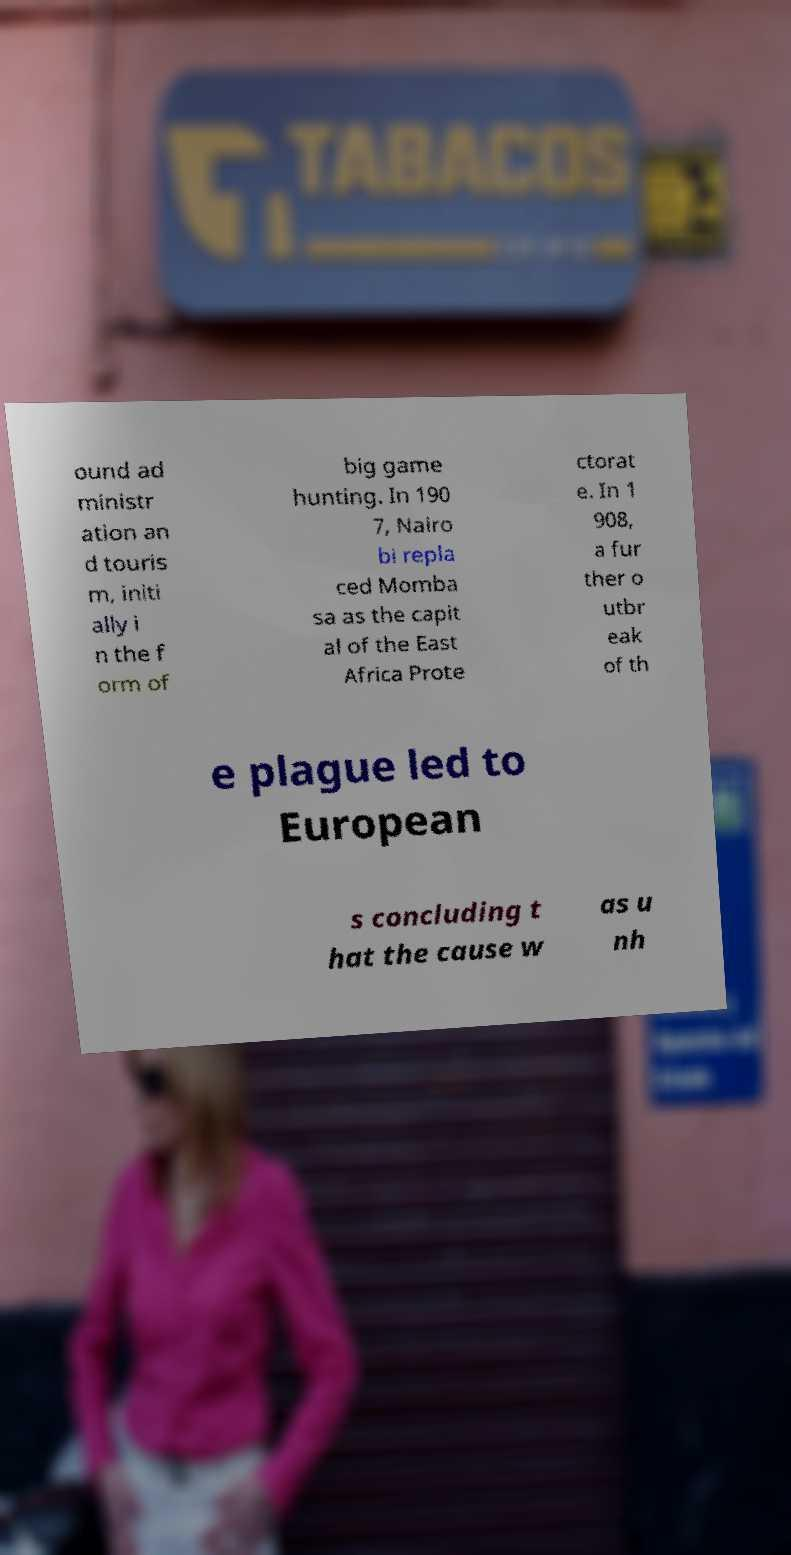Please identify and transcribe the text found in this image. ound ad ministr ation an d touris m, initi ally i n the f orm of big game hunting. In 190 7, Nairo bi repla ced Momba sa as the capit al of the East Africa Prote ctorat e. In 1 908, a fur ther o utbr eak of th e plague led to European s concluding t hat the cause w as u nh 